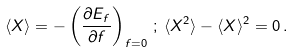Convert formula to latex. <formula><loc_0><loc_0><loc_500><loc_500>\langle X \rangle = - \left ( \frac { \partial E _ { f } } { \partial f } \right ) _ { f = 0 } \, ; \, \langle X ^ { 2 } \rangle - \langle X \rangle ^ { 2 } = 0 \, .</formula> 